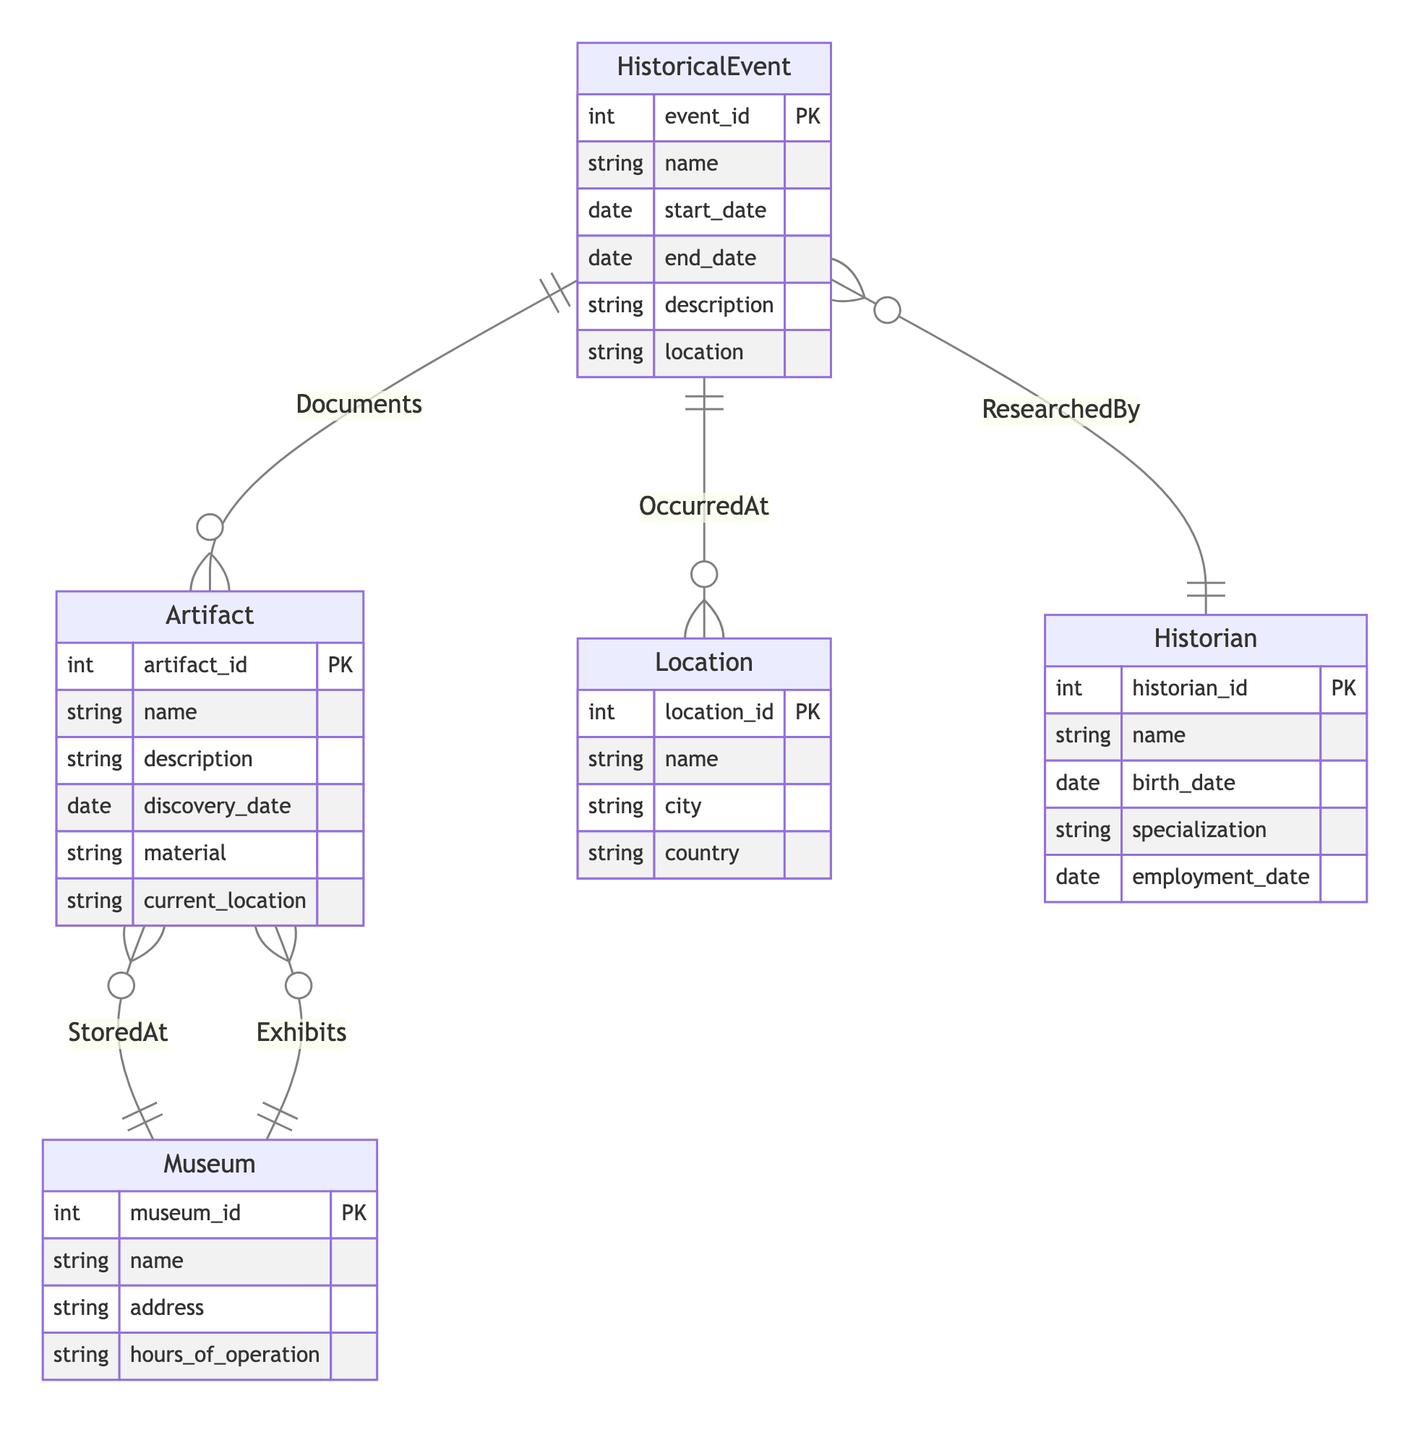What is the primary key for the HistoricalEvent entity? The primary key of the HistoricalEvent entity is indicated as "event_id" in the diagram, which serves to uniquely identify each historical event.
Answer: event_id How many attributes does the Artifact entity have? By examining the Attributes section under the Artifact entity, we can see that it has six attributes listed.
Answer: 6 What relationship connects the HistoricalEvent and Artifact entities? The diagram shows that the relationship that connects HistoricalEvent and Artifact is named "Documents". This relationship signifies that artifacts document historical events.
Answer: Documents Which entity is connected to the Museum entity through the "Exhibits" relationship? The "Exhibits" relationship connects the Museum entity to the Artifact entity, suggesting that artifacts are exhibited in museums.
Answer: Artifact What attribute describes the specialization of a Historian? The attribute that refers to the specialization of a Historian is explicitly labeled "specialization" in the diagram's Historian entity.
Answer: specialization How is the HistoricalEvent related to the Location entity? The relationship between HistoricalEvent and Location is indicated by the "OccurredAt" relationship, specifying where each historical event took place.
Answer: OccurredAt Which two entities are connected by the "ResearchedBy" relationship? The "ResearchedBy" relationship connects the Historian and HistoricalEvent entities, indicating that historians conduct research on historical events.
Answer: Historian and HistoricalEvent What is the foreign key relationship for an artifact stored in a museum? The relationship that indicates where an artifact is stored in a museum is captured by the "StoredAt" relationship, showing how artifacts relate to museums.
Answer: StoredAt How many entities are depicted in this Entity Relationship Diagram? Counting all entities in the diagram, we find five distinct entities: HistoricalEvent, Artifact, Museum, Location, and Historian.
Answer: 5 